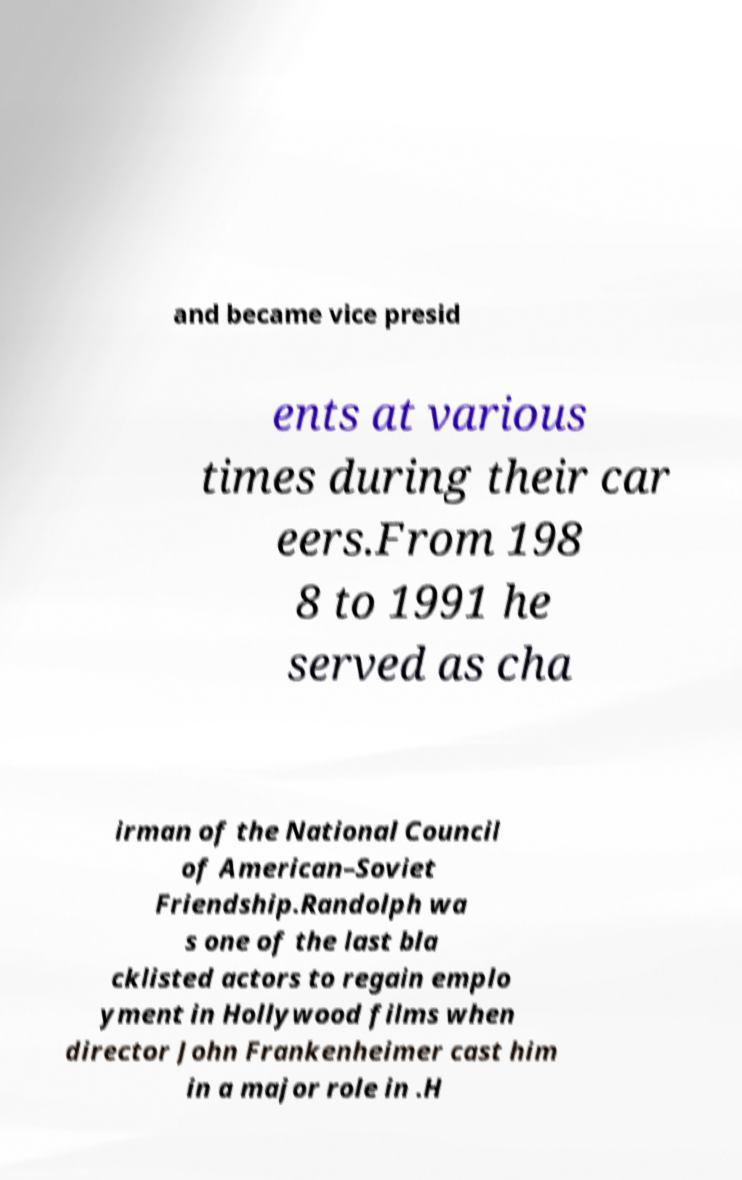Can you read and provide the text displayed in the image?This photo seems to have some interesting text. Can you extract and type it out for me? and became vice presid ents at various times during their car eers.From 198 8 to 1991 he served as cha irman of the National Council of American–Soviet Friendship.Randolph wa s one of the last bla cklisted actors to regain emplo yment in Hollywood films when director John Frankenheimer cast him in a major role in .H 